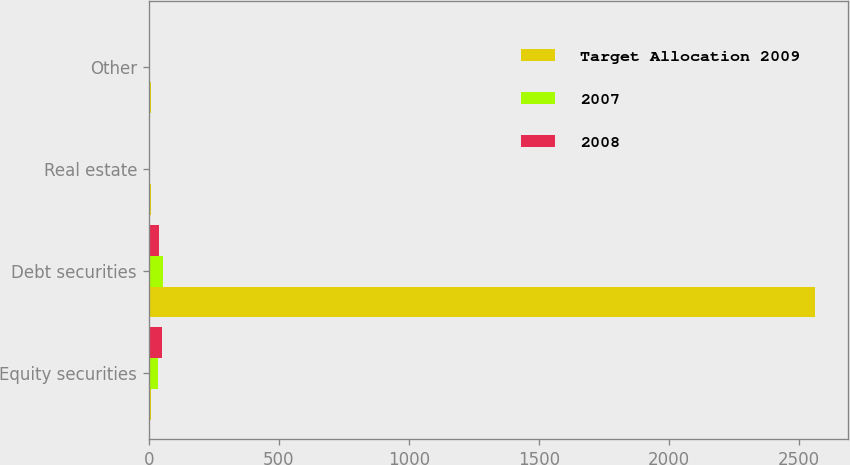Convert chart. <chart><loc_0><loc_0><loc_500><loc_500><stacked_bar_chart><ecel><fcel>Equity securities<fcel>Debt securities<fcel>Real estate<fcel>Other<nl><fcel>Target Allocation 2009<fcel>10<fcel>2560<fcel>10<fcel>10<nl><fcel>2007<fcel>36<fcel>56<fcel>6<fcel>2<nl><fcel>2008<fcel>52<fcel>40<fcel>6<fcel>2<nl></chart> 